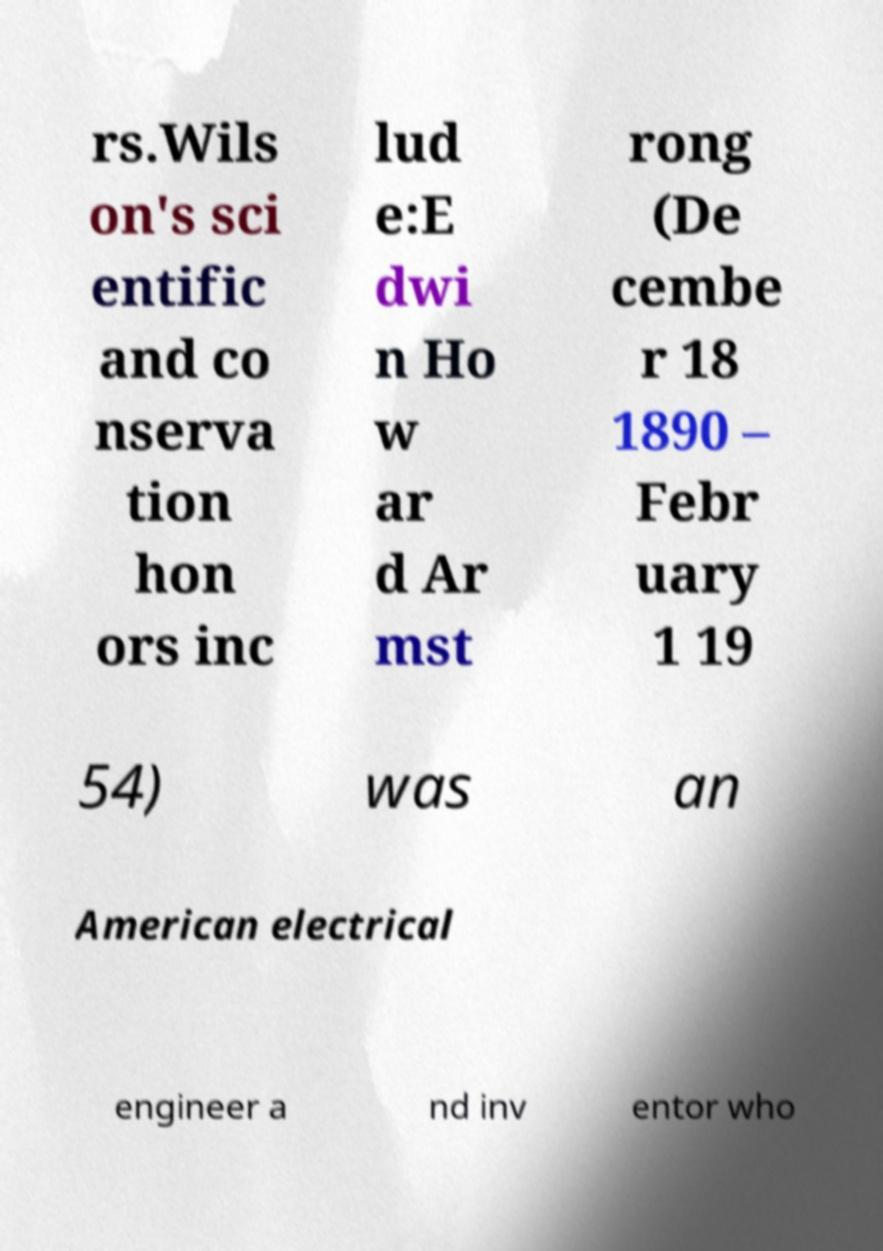Could you extract and type out the text from this image? rs.Wils on's sci entific and co nserva tion hon ors inc lud e:E dwi n Ho w ar d Ar mst rong (De cembe r 18 1890 – Febr uary 1 19 54) was an American electrical engineer a nd inv entor who 